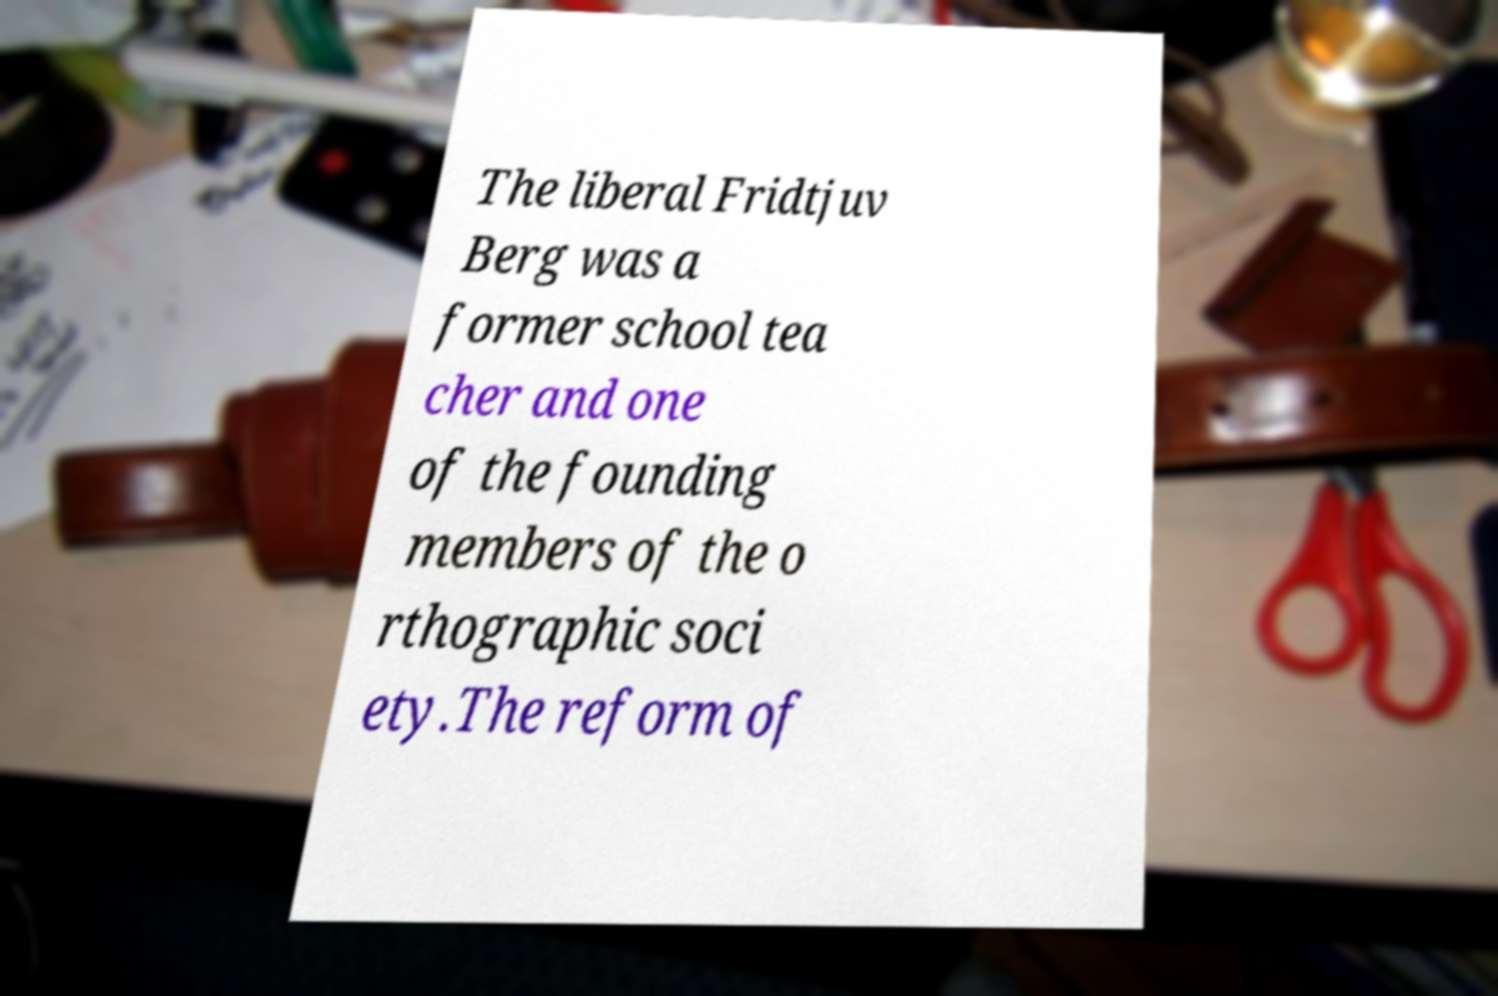Could you extract and type out the text from this image? The liberal Fridtjuv Berg was a former school tea cher and one of the founding members of the o rthographic soci ety.The reform of 